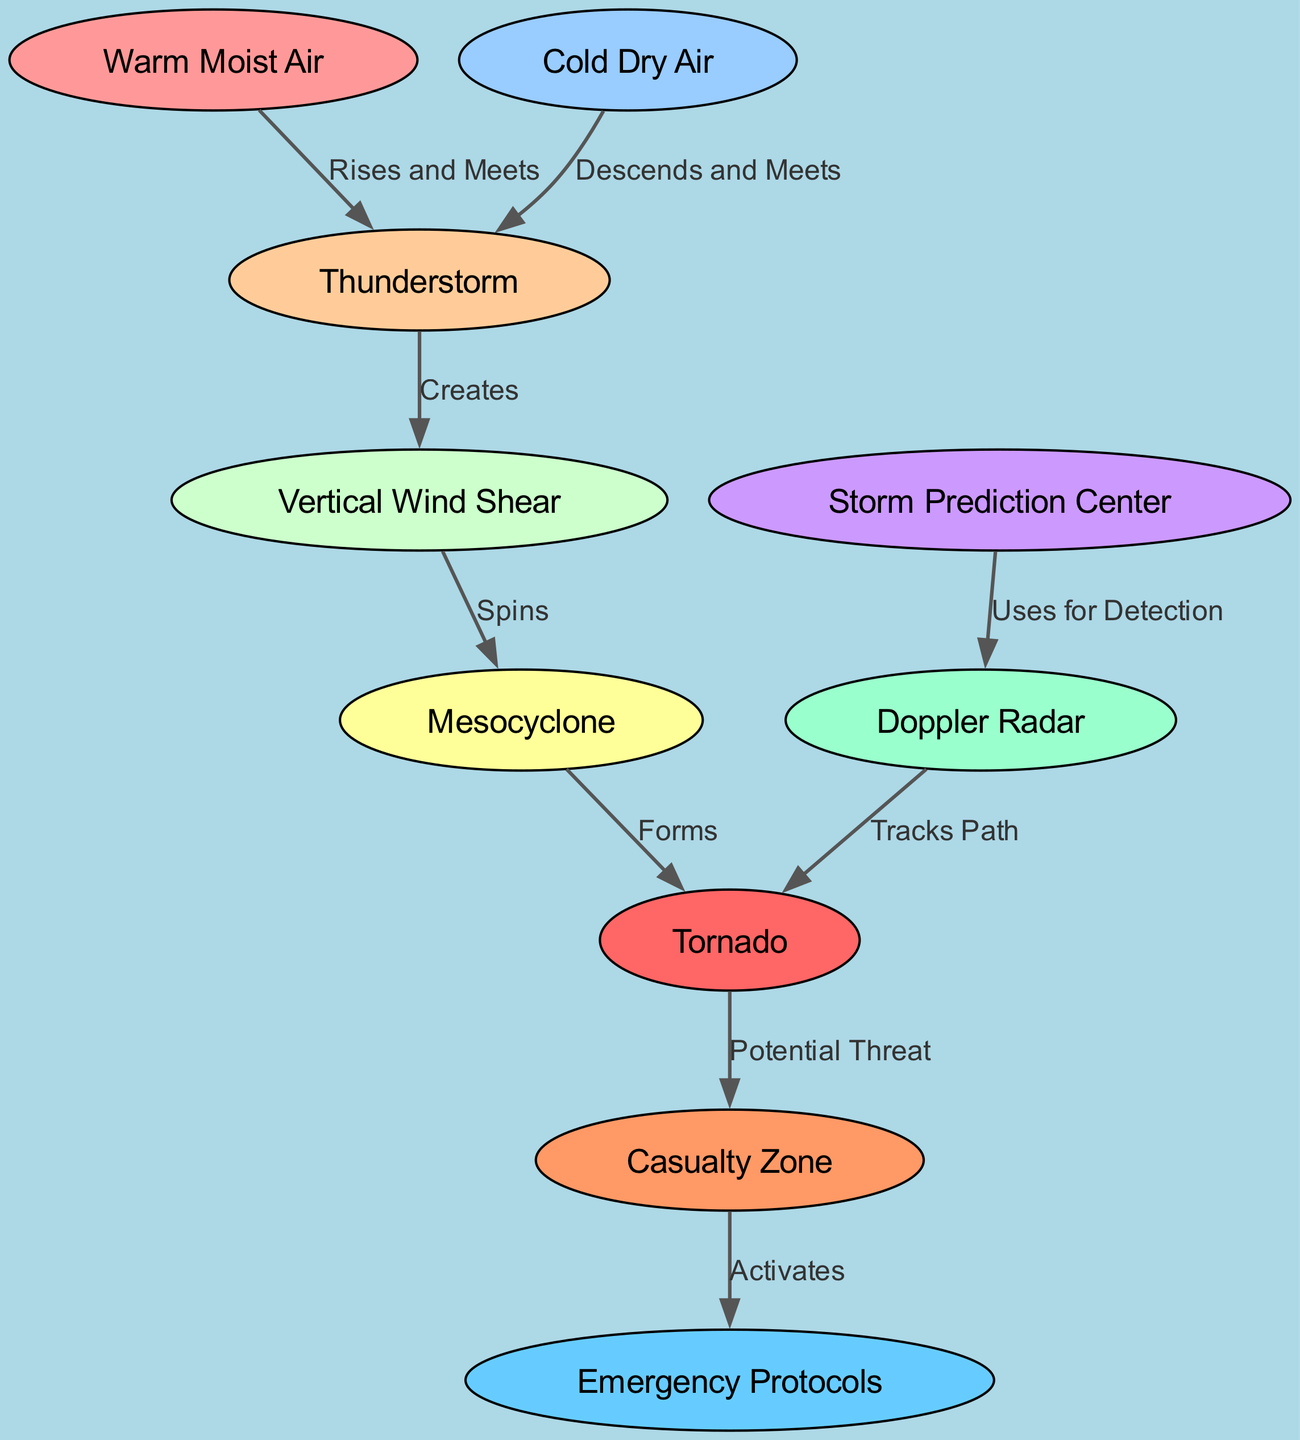What's the total number of nodes in the diagram? The diagram includes ten nodes representing different elements related to tornado formation and prediction.
Answer: 10 What does "Warm Moist Air" do when it interacts with "Thunderstorm"? According to the diagram, "Warm Moist Air" rises and meets "Thunderstorm", indicating a direct relationship where the warm air contributes to thunderstorm formation.
Answer: Rises and Meets How many edges originate from the "Mesocyclone"? There is one edge originating from "Mesocyclone" that leads to "Tornado", indicating that the mesocyclone plays a critical role in tornado formation.
Answer: 1 What activates the "Emergency Protocols"? The diagram indicates that "Emergency Protocols" are activated by the "Casualty Zone", which suggests that emergency protocols are implemented in response to the identified risks from the tornado.
Answer: Casualty Zone Which node is responsible for tracking the tornado's path? The diagram specifies that "Doppler Radar" is used for tracking the path of the tornado, highlighting its importance in tornado detection and monitoring.
Answer: Doppler Radar What does the "Storm Prediction Center" use for detection? According to the diagram, the "Storm Prediction Center" uses "Doppler Radar" for detection of tornadoes, indicating the reliance on radar technology for accurate tracking.
Answer: Uses for Detection What forms after the "Mesocyclone"? The relationship in the diagram shows that after the "Mesocyclone", a "Tornado" forms, indicating the sequence of events leading to tornado development.
Answer: Forms Describe the relationship between "Thunderstorm" and "Vertical Wind Shear". The diagram indicates that the "Thunderstorm" creates "Vertical Wind Shear", showing that the development of thunderstorms can lead to significant wind shear, which is a contributing factor to tornado formation.
Answer: Creates What potential threat does a "Tornado" represent? The diagram clearly marks that a "Tornado" has the potential threat to create a "Casualty Zone", emphasizing the risks associated with tornado activity.
Answer: Potential Threat 